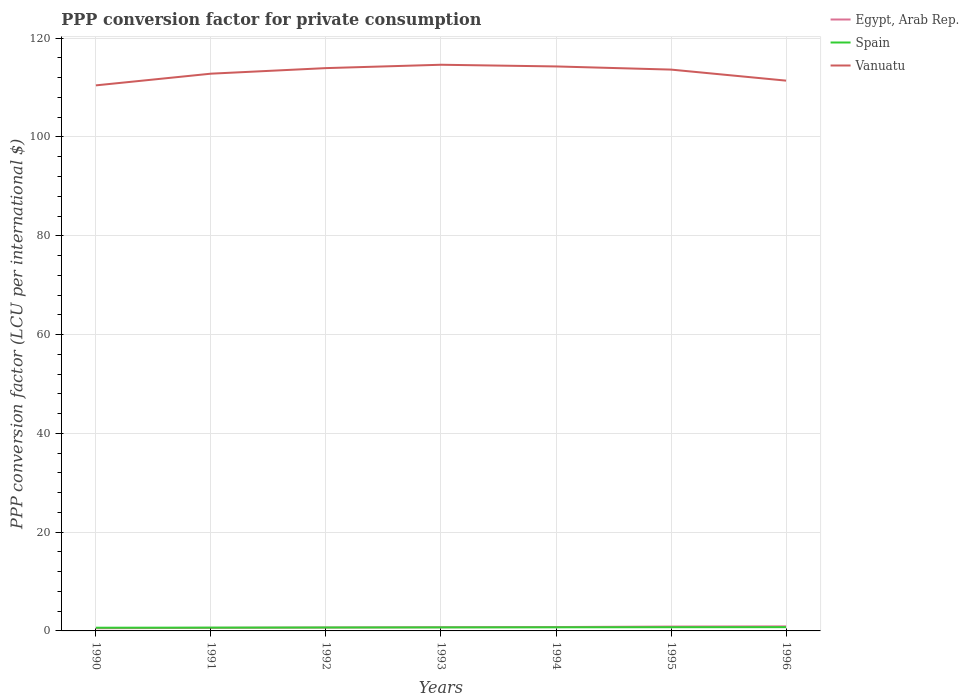How many different coloured lines are there?
Provide a succinct answer. 3. Across all years, what is the maximum PPP conversion factor for private consumption in Spain?
Provide a short and direct response. 0.65. In which year was the PPP conversion factor for private consumption in Egypt, Arab Rep. maximum?
Keep it short and to the point. 1990. What is the total PPP conversion factor for private consumption in Egypt, Arab Rep. in the graph?
Provide a short and direct response. -0.18. What is the difference between the highest and the second highest PPP conversion factor for private consumption in Vanuatu?
Provide a succinct answer. 4.17. What is the difference between the highest and the lowest PPP conversion factor for private consumption in Spain?
Keep it short and to the point. 4. Is the PPP conversion factor for private consumption in Vanuatu strictly greater than the PPP conversion factor for private consumption in Egypt, Arab Rep. over the years?
Your answer should be very brief. No. How many lines are there?
Keep it short and to the point. 3. How many years are there in the graph?
Ensure brevity in your answer.  7. What is the difference between two consecutive major ticks on the Y-axis?
Offer a very short reply. 20. Are the values on the major ticks of Y-axis written in scientific E-notation?
Offer a very short reply. No. What is the title of the graph?
Offer a terse response. PPP conversion factor for private consumption. Does "Aruba" appear as one of the legend labels in the graph?
Make the answer very short. No. What is the label or title of the Y-axis?
Give a very brief answer. PPP conversion factor (LCU per international $). What is the PPP conversion factor (LCU per international $) of Egypt, Arab Rep. in 1990?
Offer a very short reply. 0.54. What is the PPP conversion factor (LCU per international $) in Spain in 1990?
Give a very brief answer. 0.65. What is the PPP conversion factor (LCU per international $) of Vanuatu in 1990?
Your response must be concise. 110.45. What is the PPP conversion factor (LCU per international $) of Egypt, Arab Rep. in 1991?
Offer a terse response. 0.62. What is the PPP conversion factor (LCU per international $) of Spain in 1991?
Provide a succinct answer. 0.67. What is the PPP conversion factor (LCU per international $) in Vanuatu in 1991?
Make the answer very short. 112.81. What is the PPP conversion factor (LCU per international $) of Egypt, Arab Rep. in 1992?
Offer a terse response. 0.68. What is the PPP conversion factor (LCU per international $) of Spain in 1992?
Ensure brevity in your answer.  0.69. What is the PPP conversion factor (LCU per international $) in Vanuatu in 1992?
Offer a very short reply. 113.94. What is the PPP conversion factor (LCU per international $) of Egypt, Arab Rep. in 1993?
Offer a terse response. 0.75. What is the PPP conversion factor (LCU per international $) in Spain in 1993?
Make the answer very short. 0.71. What is the PPP conversion factor (LCU per international $) in Vanuatu in 1993?
Keep it short and to the point. 114.62. What is the PPP conversion factor (LCU per international $) of Egypt, Arab Rep. in 1994?
Provide a succinct answer. 0.79. What is the PPP conversion factor (LCU per international $) in Spain in 1994?
Provide a short and direct response. 0.73. What is the PPP conversion factor (LCU per international $) in Vanuatu in 1994?
Make the answer very short. 114.28. What is the PPP conversion factor (LCU per international $) of Egypt, Arab Rep. in 1995?
Ensure brevity in your answer.  0.88. What is the PPP conversion factor (LCU per international $) in Spain in 1995?
Offer a terse response. 0.75. What is the PPP conversion factor (LCU per international $) of Vanuatu in 1995?
Your response must be concise. 113.64. What is the PPP conversion factor (LCU per international $) in Egypt, Arab Rep. in 1996?
Make the answer very short. 0.92. What is the PPP conversion factor (LCU per international $) in Spain in 1996?
Provide a succinct answer. 0.76. What is the PPP conversion factor (LCU per international $) in Vanuatu in 1996?
Your response must be concise. 111.41. Across all years, what is the maximum PPP conversion factor (LCU per international $) of Egypt, Arab Rep.?
Your answer should be very brief. 0.92. Across all years, what is the maximum PPP conversion factor (LCU per international $) in Spain?
Give a very brief answer. 0.76. Across all years, what is the maximum PPP conversion factor (LCU per international $) of Vanuatu?
Your response must be concise. 114.62. Across all years, what is the minimum PPP conversion factor (LCU per international $) in Egypt, Arab Rep.?
Offer a very short reply. 0.54. Across all years, what is the minimum PPP conversion factor (LCU per international $) of Spain?
Your answer should be compact. 0.65. Across all years, what is the minimum PPP conversion factor (LCU per international $) of Vanuatu?
Provide a short and direct response. 110.45. What is the total PPP conversion factor (LCU per international $) of Egypt, Arab Rep. in the graph?
Your response must be concise. 5.18. What is the total PPP conversion factor (LCU per international $) in Spain in the graph?
Offer a very short reply. 4.98. What is the total PPP conversion factor (LCU per international $) in Vanuatu in the graph?
Your answer should be compact. 791.15. What is the difference between the PPP conversion factor (LCU per international $) in Egypt, Arab Rep. in 1990 and that in 1991?
Your answer should be compact. -0.08. What is the difference between the PPP conversion factor (LCU per international $) of Spain in 1990 and that in 1991?
Offer a terse response. -0.02. What is the difference between the PPP conversion factor (LCU per international $) of Vanuatu in 1990 and that in 1991?
Provide a succinct answer. -2.37. What is the difference between the PPP conversion factor (LCU per international $) in Egypt, Arab Rep. in 1990 and that in 1992?
Offer a very short reply. -0.14. What is the difference between the PPP conversion factor (LCU per international $) in Spain in 1990 and that in 1992?
Offer a very short reply. -0.05. What is the difference between the PPP conversion factor (LCU per international $) in Vanuatu in 1990 and that in 1992?
Provide a short and direct response. -3.49. What is the difference between the PPP conversion factor (LCU per international $) in Egypt, Arab Rep. in 1990 and that in 1993?
Make the answer very short. -0.2. What is the difference between the PPP conversion factor (LCU per international $) of Spain in 1990 and that in 1993?
Offer a very short reply. -0.06. What is the difference between the PPP conversion factor (LCU per international $) of Vanuatu in 1990 and that in 1993?
Your answer should be compact. -4.17. What is the difference between the PPP conversion factor (LCU per international $) in Egypt, Arab Rep. in 1990 and that in 1994?
Make the answer very short. -0.25. What is the difference between the PPP conversion factor (LCU per international $) in Spain in 1990 and that in 1994?
Give a very brief answer. -0.08. What is the difference between the PPP conversion factor (LCU per international $) in Vanuatu in 1990 and that in 1994?
Offer a very short reply. -3.83. What is the difference between the PPP conversion factor (LCU per international $) in Egypt, Arab Rep. in 1990 and that in 1995?
Your answer should be very brief. -0.34. What is the difference between the PPP conversion factor (LCU per international $) in Spain in 1990 and that in 1995?
Provide a succinct answer. -0.1. What is the difference between the PPP conversion factor (LCU per international $) in Vanuatu in 1990 and that in 1995?
Offer a terse response. -3.19. What is the difference between the PPP conversion factor (LCU per international $) of Egypt, Arab Rep. in 1990 and that in 1996?
Your response must be concise. -0.38. What is the difference between the PPP conversion factor (LCU per international $) in Spain in 1990 and that in 1996?
Make the answer very short. -0.11. What is the difference between the PPP conversion factor (LCU per international $) of Vanuatu in 1990 and that in 1996?
Ensure brevity in your answer.  -0.96. What is the difference between the PPP conversion factor (LCU per international $) of Egypt, Arab Rep. in 1991 and that in 1992?
Make the answer very short. -0.06. What is the difference between the PPP conversion factor (LCU per international $) of Spain in 1991 and that in 1992?
Your response must be concise. -0.03. What is the difference between the PPP conversion factor (LCU per international $) in Vanuatu in 1991 and that in 1992?
Ensure brevity in your answer.  -1.13. What is the difference between the PPP conversion factor (LCU per international $) of Egypt, Arab Rep. in 1991 and that in 1993?
Provide a short and direct response. -0.12. What is the difference between the PPP conversion factor (LCU per international $) of Spain in 1991 and that in 1993?
Keep it short and to the point. -0.04. What is the difference between the PPP conversion factor (LCU per international $) in Vanuatu in 1991 and that in 1993?
Offer a very short reply. -1.81. What is the difference between the PPP conversion factor (LCU per international $) of Egypt, Arab Rep. in 1991 and that in 1994?
Offer a very short reply. -0.16. What is the difference between the PPP conversion factor (LCU per international $) in Spain in 1991 and that in 1994?
Keep it short and to the point. -0.06. What is the difference between the PPP conversion factor (LCU per international $) of Vanuatu in 1991 and that in 1994?
Ensure brevity in your answer.  -1.47. What is the difference between the PPP conversion factor (LCU per international $) in Egypt, Arab Rep. in 1991 and that in 1995?
Ensure brevity in your answer.  -0.26. What is the difference between the PPP conversion factor (LCU per international $) in Spain in 1991 and that in 1995?
Give a very brief answer. -0.08. What is the difference between the PPP conversion factor (LCU per international $) in Vanuatu in 1991 and that in 1995?
Offer a very short reply. -0.83. What is the difference between the PPP conversion factor (LCU per international $) of Egypt, Arab Rep. in 1991 and that in 1996?
Offer a terse response. -0.3. What is the difference between the PPP conversion factor (LCU per international $) of Spain in 1991 and that in 1996?
Offer a very short reply. -0.09. What is the difference between the PPP conversion factor (LCU per international $) of Vanuatu in 1991 and that in 1996?
Provide a succinct answer. 1.41. What is the difference between the PPP conversion factor (LCU per international $) in Egypt, Arab Rep. in 1992 and that in 1993?
Keep it short and to the point. -0.06. What is the difference between the PPP conversion factor (LCU per international $) of Spain in 1992 and that in 1993?
Provide a short and direct response. -0.02. What is the difference between the PPP conversion factor (LCU per international $) in Vanuatu in 1992 and that in 1993?
Your answer should be very brief. -0.68. What is the difference between the PPP conversion factor (LCU per international $) in Egypt, Arab Rep. in 1992 and that in 1994?
Your response must be concise. -0.1. What is the difference between the PPP conversion factor (LCU per international $) of Spain in 1992 and that in 1994?
Your answer should be compact. -0.04. What is the difference between the PPP conversion factor (LCU per international $) of Vanuatu in 1992 and that in 1994?
Make the answer very short. -0.34. What is the difference between the PPP conversion factor (LCU per international $) in Egypt, Arab Rep. in 1992 and that in 1995?
Provide a succinct answer. -0.2. What is the difference between the PPP conversion factor (LCU per international $) in Spain in 1992 and that in 1995?
Ensure brevity in your answer.  -0.06. What is the difference between the PPP conversion factor (LCU per international $) in Vanuatu in 1992 and that in 1995?
Give a very brief answer. 0.3. What is the difference between the PPP conversion factor (LCU per international $) of Egypt, Arab Rep. in 1992 and that in 1996?
Your answer should be compact. -0.24. What is the difference between the PPP conversion factor (LCU per international $) in Spain in 1992 and that in 1996?
Provide a short and direct response. -0.07. What is the difference between the PPP conversion factor (LCU per international $) in Vanuatu in 1992 and that in 1996?
Your answer should be compact. 2.54. What is the difference between the PPP conversion factor (LCU per international $) of Egypt, Arab Rep. in 1993 and that in 1994?
Your answer should be very brief. -0.04. What is the difference between the PPP conversion factor (LCU per international $) in Spain in 1993 and that in 1994?
Provide a short and direct response. -0.02. What is the difference between the PPP conversion factor (LCU per international $) in Vanuatu in 1993 and that in 1994?
Make the answer very short. 0.34. What is the difference between the PPP conversion factor (LCU per international $) in Egypt, Arab Rep. in 1993 and that in 1995?
Provide a short and direct response. -0.14. What is the difference between the PPP conversion factor (LCU per international $) of Spain in 1993 and that in 1995?
Offer a terse response. -0.04. What is the difference between the PPP conversion factor (LCU per international $) of Vanuatu in 1993 and that in 1995?
Keep it short and to the point. 0.98. What is the difference between the PPP conversion factor (LCU per international $) in Egypt, Arab Rep. in 1993 and that in 1996?
Your answer should be compact. -0.18. What is the difference between the PPP conversion factor (LCU per international $) in Spain in 1993 and that in 1996?
Give a very brief answer. -0.05. What is the difference between the PPP conversion factor (LCU per international $) of Vanuatu in 1993 and that in 1996?
Keep it short and to the point. 3.22. What is the difference between the PPP conversion factor (LCU per international $) of Egypt, Arab Rep. in 1994 and that in 1995?
Give a very brief answer. -0.1. What is the difference between the PPP conversion factor (LCU per international $) of Spain in 1994 and that in 1995?
Give a very brief answer. -0.02. What is the difference between the PPP conversion factor (LCU per international $) in Vanuatu in 1994 and that in 1995?
Make the answer very short. 0.64. What is the difference between the PPP conversion factor (LCU per international $) of Egypt, Arab Rep. in 1994 and that in 1996?
Keep it short and to the point. -0.14. What is the difference between the PPP conversion factor (LCU per international $) in Spain in 1994 and that in 1996?
Make the answer very short. -0.03. What is the difference between the PPP conversion factor (LCU per international $) of Vanuatu in 1994 and that in 1996?
Give a very brief answer. 2.88. What is the difference between the PPP conversion factor (LCU per international $) in Egypt, Arab Rep. in 1995 and that in 1996?
Your response must be concise. -0.04. What is the difference between the PPP conversion factor (LCU per international $) of Spain in 1995 and that in 1996?
Provide a succinct answer. -0.01. What is the difference between the PPP conversion factor (LCU per international $) of Vanuatu in 1995 and that in 1996?
Ensure brevity in your answer.  2.24. What is the difference between the PPP conversion factor (LCU per international $) in Egypt, Arab Rep. in 1990 and the PPP conversion factor (LCU per international $) in Spain in 1991?
Ensure brevity in your answer.  -0.13. What is the difference between the PPP conversion factor (LCU per international $) in Egypt, Arab Rep. in 1990 and the PPP conversion factor (LCU per international $) in Vanuatu in 1991?
Ensure brevity in your answer.  -112.27. What is the difference between the PPP conversion factor (LCU per international $) of Spain in 1990 and the PPP conversion factor (LCU per international $) of Vanuatu in 1991?
Your answer should be compact. -112.17. What is the difference between the PPP conversion factor (LCU per international $) in Egypt, Arab Rep. in 1990 and the PPP conversion factor (LCU per international $) in Spain in 1992?
Make the answer very short. -0.15. What is the difference between the PPP conversion factor (LCU per international $) of Egypt, Arab Rep. in 1990 and the PPP conversion factor (LCU per international $) of Vanuatu in 1992?
Your response must be concise. -113.4. What is the difference between the PPP conversion factor (LCU per international $) in Spain in 1990 and the PPP conversion factor (LCU per international $) in Vanuatu in 1992?
Make the answer very short. -113.29. What is the difference between the PPP conversion factor (LCU per international $) of Egypt, Arab Rep. in 1990 and the PPP conversion factor (LCU per international $) of Spain in 1993?
Your response must be concise. -0.17. What is the difference between the PPP conversion factor (LCU per international $) in Egypt, Arab Rep. in 1990 and the PPP conversion factor (LCU per international $) in Vanuatu in 1993?
Provide a short and direct response. -114.08. What is the difference between the PPP conversion factor (LCU per international $) in Spain in 1990 and the PPP conversion factor (LCU per international $) in Vanuatu in 1993?
Your response must be concise. -113.97. What is the difference between the PPP conversion factor (LCU per international $) in Egypt, Arab Rep. in 1990 and the PPP conversion factor (LCU per international $) in Spain in 1994?
Give a very brief answer. -0.19. What is the difference between the PPP conversion factor (LCU per international $) of Egypt, Arab Rep. in 1990 and the PPP conversion factor (LCU per international $) of Vanuatu in 1994?
Your response must be concise. -113.74. What is the difference between the PPP conversion factor (LCU per international $) of Spain in 1990 and the PPP conversion factor (LCU per international $) of Vanuatu in 1994?
Keep it short and to the point. -113.63. What is the difference between the PPP conversion factor (LCU per international $) in Egypt, Arab Rep. in 1990 and the PPP conversion factor (LCU per international $) in Spain in 1995?
Your response must be concise. -0.21. What is the difference between the PPP conversion factor (LCU per international $) in Egypt, Arab Rep. in 1990 and the PPP conversion factor (LCU per international $) in Vanuatu in 1995?
Make the answer very short. -113.1. What is the difference between the PPP conversion factor (LCU per international $) of Spain in 1990 and the PPP conversion factor (LCU per international $) of Vanuatu in 1995?
Offer a terse response. -112.99. What is the difference between the PPP conversion factor (LCU per international $) in Egypt, Arab Rep. in 1990 and the PPP conversion factor (LCU per international $) in Spain in 1996?
Ensure brevity in your answer.  -0.22. What is the difference between the PPP conversion factor (LCU per international $) of Egypt, Arab Rep. in 1990 and the PPP conversion factor (LCU per international $) of Vanuatu in 1996?
Provide a short and direct response. -110.87. What is the difference between the PPP conversion factor (LCU per international $) of Spain in 1990 and the PPP conversion factor (LCU per international $) of Vanuatu in 1996?
Provide a succinct answer. -110.76. What is the difference between the PPP conversion factor (LCU per international $) of Egypt, Arab Rep. in 1991 and the PPP conversion factor (LCU per international $) of Spain in 1992?
Keep it short and to the point. -0.07. What is the difference between the PPP conversion factor (LCU per international $) of Egypt, Arab Rep. in 1991 and the PPP conversion factor (LCU per international $) of Vanuatu in 1992?
Make the answer very short. -113.32. What is the difference between the PPP conversion factor (LCU per international $) of Spain in 1991 and the PPP conversion factor (LCU per international $) of Vanuatu in 1992?
Your answer should be very brief. -113.27. What is the difference between the PPP conversion factor (LCU per international $) of Egypt, Arab Rep. in 1991 and the PPP conversion factor (LCU per international $) of Spain in 1993?
Keep it short and to the point. -0.09. What is the difference between the PPP conversion factor (LCU per international $) of Egypt, Arab Rep. in 1991 and the PPP conversion factor (LCU per international $) of Vanuatu in 1993?
Ensure brevity in your answer.  -114. What is the difference between the PPP conversion factor (LCU per international $) in Spain in 1991 and the PPP conversion factor (LCU per international $) in Vanuatu in 1993?
Your response must be concise. -113.95. What is the difference between the PPP conversion factor (LCU per international $) of Egypt, Arab Rep. in 1991 and the PPP conversion factor (LCU per international $) of Spain in 1994?
Offer a very short reply. -0.11. What is the difference between the PPP conversion factor (LCU per international $) in Egypt, Arab Rep. in 1991 and the PPP conversion factor (LCU per international $) in Vanuatu in 1994?
Provide a succinct answer. -113.66. What is the difference between the PPP conversion factor (LCU per international $) of Spain in 1991 and the PPP conversion factor (LCU per international $) of Vanuatu in 1994?
Your response must be concise. -113.61. What is the difference between the PPP conversion factor (LCU per international $) in Egypt, Arab Rep. in 1991 and the PPP conversion factor (LCU per international $) in Spain in 1995?
Your answer should be very brief. -0.13. What is the difference between the PPP conversion factor (LCU per international $) of Egypt, Arab Rep. in 1991 and the PPP conversion factor (LCU per international $) of Vanuatu in 1995?
Make the answer very short. -113.02. What is the difference between the PPP conversion factor (LCU per international $) in Spain in 1991 and the PPP conversion factor (LCU per international $) in Vanuatu in 1995?
Give a very brief answer. -112.97. What is the difference between the PPP conversion factor (LCU per international $) in Egypt, Arab Rep. in 1991 and the PPP conversion factor (LCU per international $) in Spain in 1996?
Your response must be concise. -0.14. What is the difference between the PPP conversion factor (LCU per international $) of Egypt, Arab Rep. in 1991 and the PPP conversion factor (LCU per international $) of Vanuatu in 1996?
Ensure brevity in your answer.  -110.79. What is the difference between the PPP conversion factor (LCU per international $) in Spain in 1991 and the PPP conversion factor (LCU per international $) in Vanuatu in 1996?
Offer a terse response. -110.74. What is the difference between the PPP conversion factor (LCU per international $) in Egypt, Arab Rep. in 1992 and the PPP conversion factor (LCU per international $) in Spain in 1993?
Make the answer very short. -0.03. What is the difference between the PPP conversion factor (LCU per international $) of Egypt, Arab Rep. in 1992 and the PPP conversion factor (LCU per international $) of Vanuatu in 1993?
Offer a terse response. -113.94. What is the difference between the PPP conversion factor (LCU per international $) of Spain in 1992 and the PPP conversion factor (LCU per international $) of Vanuatu in 1993?
Your answer should be compact. -113.93. What is the difference between the PPP conversion factor (LCU per international $) of Egypt, Arab Rep. in 1992 and the PPP conversion factor (LCU per international $) of Spain in 1994?
Make the answer very short. -0.05. What is the difference between the PPP conversion factor (LCU per international $) of Egypt, Arab Rep. in 1992 and the PPP conversion factor (LCU per international $) of Vanuatu in 1994?
Your answer should be very brief. -113.6. What is the difference between the PPP conversion factor (LCU per international $) in Spain in 1992 and the PPP conversion factor (LCU per international $) in Vanuatu in 1994?
Offer a terse response. -113.59. What is the difference between the PPP conversion factor (LCU per international $) in Egypt, Arab Rep. in 1992 and the PPP conversion factor (LCU per international $) in Spain in 1995?
Provide a succinct answer. -0.07. What is the difference between the PPP conversion factor (LCU per international $) of Egypt, Arab Rep. in 1992 and the PPP conversion factor (LCU per international $) of Vanuatu in 1995?
Keep it short and to the point. -112.96. What is the difference between the PPP conversion factor (LCU per international $) in Spain in 1992 and the PPP conversion factor (LCU per international $) in Vanuatu in 1995?
Offer a very short reply. -112.95. What is the difference between the PPP conversion factor (LCU per international $) in Egypt, Arab Rep. in 1992 and the PPP conversion factor (LCU per international $) in Spain in 1996?
Ensure brevity in your answer.  -0.08. What is the difference between the PPP conversion factor (LCU per international $) in Egypt, Arab Rep. in 1992 and the PPP conversion factor (LCU per international $) in Vanuatu in 1996?
Your answer should be very brief. -110.72. What is the difference between the PPP conversion factor (LCU per international $) of Spain in 1992 and the PPP conversion factor (LCU per international $) of Vanuatu in 1996?
Your answer should be compact. -110.71. What is the difference between the PPP conversion factor (LCU per international $) in Egypt, Arab Rep. in 1993 and the PPP conversion factor (LCU per international $) in Spain in 1994?
Keep it short and to the point. 0.01. What is the difference between the PPP conversion factor (LCU per international $) in Egypt, Arab Rep. in 1993 and the PPP conversion factor (LCU per international $) in Vanuatu in 1994?
Your answer should be very brief. -113.54. What is the difference between the PPP conversion factor (LCU per international $) in Spain in 1993 and the PPP conversion factor (LCU per international $) in Vanuatu in 1994?
Your response must be concise. -113.57. What is the difference between the PPP conversion factor (LCU per international $) of Egypt, Arab Rep. in 1993 and the PPP conversion factor (LCU per international $) of Spain in 1995?
Make the answer very short. -0.01. What is the difference between the PPP conversion factor (LCU per international $) of Egypt, Arab Rep. in 1993 and the PPP conversion factor (LCU per international $) of Vanuatu in 1995?
Your answer should be compact. -112.9. What is the difference between the PPP conversion factor (LCU per international $) in Spain in 1993 and the PPP conversion factor (LCU per international $) in Vanuatu in 1995?
Give a very brief answer. -112.93. What is the difference between the PPP conversion factor (LCU per international $) in Egypt, Arab Rep. in 1993 and the PPP conversion factor (LCU per international $) in Spain in 1996?
Your answer should be very brief. -0.02. What is the difference between the PPP conversion factor (LCU per international $) of Egypt, Arab Rep. in 1993 and the PPP conversion factor (LCU per international $) of Vanuatu in 1996?
Keep it short and to the point. -110.66. What is the difference between the PPP conversion factor (LCU per international $) in Spain in 1993 and the PPP conversion factor (LCU per international $) in Vanuatu in 1996?
Provide a short and direct response. -110.69. What is the difference between the PPP conversion factor (LCU per international $) of Egypt, Arab Rep. in 1994 and the PPP conversion factor (LCU per international $) of Spain in 1995?
Make the answer very short. 0.03. What is the difference between the PPP conversion factor (LCU per international $) in Egypt, Arab Rep. in 1994 and the PPP conversion factor (LCU per international $) in Vanuatu in 1995?
Offer a very short reply. -112.86. What is the difference between the PPP conversion factor (LCU per international $) of Spain in 1994 and the PPP conversion factor (LCU per international $) of Vanuatu in 1995?
Your answer should be compact. -112.91. What is the difference between the PPP conversion factor (LCU per international $) in Egypt, Arab Rep. in 1994 and the PPP conversion factor (LCU per international $) in Spain in 1996?
Your answer should be very brief. 0.02. What is the difference between the PPP conversion factor (LCU per international $) of Egypt, Arab Rep. in 1994 and the PPP conversion factor (LCU per international $) of Vanuatu in 1996?
Your answer should be very brief. -110.62. What is the difference between the PPP conversion factor (LCU per international $) in Spain in 1994 and the PPP conversion factor (LCU per international $) in Vanuatu in 1996?
Offer a terse response. -110.67. What is the difference between the PPP conversion factor (LCU per international $) in Egypt, Arab Rep. in 1995 and the PPP conversion factor (LCU per international $) in Spain in 1996?
Your response must be concise. 0.12. What is the difference between the PPP conversion factor (LCU per international $) in Egypt, Arab Rep. in 1995 and the PPP conversion factor (LCU per international $) in Vanuatu in 1996?
Offer a very short reply. -110.52. What is the difference between the PPP conversion factor (LCU per international $) in Spain in 1995 and the PPP conversion factor (LCU per international $) in Vanuatu in 1996?
Your answer should be very brief. -110.65. What is the average PPP conversion factor (LCU per international $) of Egypt, Arab Rep. per year?
Provide a succinct answer. 0.74. What is the average PPP conversion factor (LCU per international $) of Spain per year?
Your answer should be very brief. 0.71. What is the average PPP conversion factor (LCU per international $) in Vanuatu per year?
Give a very brief answer. 113.02. In the year 1990, what is the difference between the PPP conversion factor (LCU per international $) of Egypt, Arab Rep. and PPP conversion factor (LCU per international $) of Spain?
Your response must be concise. -0.11. In the year 1990, what is the difference between the PPP conversion factor (LCU per international $) in Egypt, Arab Rep. and PPP conversion factor (LCU per international $) in Vanuatu?
Your response must be concise. -109.91. In the year 1990, what is the difference between the PPP conversion factor (LCU per international $) of Spain and PPP conversion factor (LCU per international $) of Vanuatu?
Offer a terse response. -109.8. In the year 1991, what is the difference between the PPP conversion factor (LCU per international $) in Egypt, Arab Rep. and PPP conversion factor (LCU per international $) in Spain?
Ensure brevity in your answer.  -0.05. In the year 1991, what is the difference between the PPP conversion factor (LCU per international $) in Egypt, Arab Rep. and PPP conversion factor (LCU per international $) in Vanuatu?
Your answer should be very brief. -112.19. In the year 1991, what is the difference between the PPP conversion factor (LCU per international $) in Spain and PPP conversion factor (LCU per international $) in Vanuatu?
Your answer should be very brief. -112.15. In the year 1992, what is the difference between the PPP conversion factor (LCU per international $) of Egypt, Arab Rep. and PPP conversion factor (LCU per international $) of Spain?
Offer a terse response. -0.01. In the year 1992, what is the difference between the PPP conversion factor (LCU per international $) of Egypt, Arab Rep. and PPP conversion factor (LCU per international $) of Vanuatu?
Make the answer very short. -113.26. In the year 1992, what is the difference between the PPP conversion factor (LCU per international $) in Spain and PPP conversion factor (LCU per international $) in Vanuatu?
Your answer should be very brief. -113.25. In the year 1993, what is the difference between the PPP conversion factor (LCU per international $) of Egypt, Arab Rep. and PPP conversion factor (LCU per international $) of Spain?
Your answer should be compact. 0.03. In the year 1993, what is the difference between the PPP conversion factor (LCU per international $) of Egypt, Arab Rep. and PPP conversion factor (LCU per international $) of Vanuatu?
Offer a very short reply. -113.88. In the year 1993, what is the difference between the PPP conversion factor (LCU per international $) of Spain and PPP conversion factor (LCU per international $) of Vanuatu?
Your answer should be very brief. -113.91. In the year 1994, what is the difference between the PPP conversion factor (LCU per international $) in Egypt, Arab Rep. and PPP conversion factor (LCU per international $) in Spain?
Make the answer very short. 0.05. In the year 1994, what is the difference between the PPP conversion factor (LCU per international $) of Egypt, Arab Rep. and PPP conversion factor (LCU per international $) of Vanuatu?
Make the answer very short. -113.5. In the year 1994, what is the difference between the PPP conversion factor (LCU per international $) in Spain and PPP conversion factor (LCU per international $) in Vanuatu?
Give a very brief answer. -113.55. In the year 1995, what is the difference between the PPP conversion factor (LCU per international $) in Egypt, Arab Rep. and PPP conversion factor (LCU per international $) in Spain?
Provide a succinct answer. 0.13. In the year 1995, what is the difference between the PPP conversion factor (LCU per international $) in Egypt, Arab Rep. and PPP conversion factor (LCU per international $) in Vanuatu?
Your answer should be compact. -112.76. In the year 1995, what is the difference between the PPP conversion factor (LCU per international $) in Spain and PPP conversion factor (LCU per international $) in Vanuatu?
Offer a very short reply. -112.89. In the year 1996, what is the difference between the PPP conversion factor (LCU per international $) in Egypt, Arab Rep. and PPP conversion factor (LCU per international $) in Spain?
Keep it short and to the point. 0.16. In the year 1996, what is the difference between the PPP conversion factor (LCU per international $) of Egypt, Arab Rep. and PPP conversion factor (LCU per international $) of Vanuatu?
Offer a terse response. -110.49. In the year 1996, what is the difference between the PPP conversion factor (LCU per international $) of Spain and PPP conversion factor (LCU per international $) of Vanuatu?
Offer a very short reply. -110.64. What is the ratio of the PPP conversion factor (LCU per international $) of Egypt, Arab Rep. in 1990 to that in 1991?
Give a very brief answer. 0.87. What is the ratio of the PPP conversion factor (LCU per international $) in Spain in 1990 to that in 1991?
Offer a terse response. 0.97. What is the ratio of the PPP conversion factor (LCU per international $) of Vanuatu in 1990 to that in 1991?
Provide a succinct answer. 0.98. What is the ratio of the PPP conversion factor (LCU per international $) of Egypt, Arab Rep. in 1990 to that in 1992?
Your answer should be compact. 0.79. What is the ratio of the PPP conversion factor (LCU per international $) in Spain in 1990 to that in 1992?
Your answer should be compact. 0.93. What is the ratio of the PPP conversion factor (LCU per international $) in Vanuatu in 1990 to that in 1992?
Offer a terse response. 0.97. What is the ratio of the PPP conversion factor (LCU per international $) in Egypt, Arab Rep. in 1990 to that in 1993?
Offer a very short reply. 0.72. What is the ratio of the PPP conversion factor (LCU per international $) in Spain in 1990 to that in 1993?
Give a very brief answer. 0.91. What is the ratio of the PPP conversion factor (LCU per international $) of Vanuatu in 1990 to that in 1993?
Ensure brevity in your answer.  0.96. What is the ratio of the PPP conversion factor (LCU per international $) in Egypt, Arab Rep. in 1990 to that in 1994?
Offer a terse response. 0.69. What is the ratio of the PPP conversion factor (LCU per international $) in Spain in 1990 to that in 1994?
Your answer should be very brief. 0.89. What is the ratio of the PPP conversion factor (LCU per international $) in Vanuatu in 1990 to that in 1994?
Keep it short and to the point. 0.97. What is the ratio of the PPP conversion factor (LCU per international $) in Egypt, Arab Rep. in 1990 to that in 1995?
Offer a very short reply. 0.61. What is the ratio of the PPP conversion factor (LCU per international $) of Spain in 1990 to that in 1995?
Keep it short and to the point. 0.86. What is the ratio of the PPP conversion factor (LCU per international $) of Vanuatu in 1990 to that in 1995?
Keep it short and to the point. 0.97. What is the ratio of the PPP conversion factor (LCU per international $) in Egypt, Arab Rep. in 1990 to that in 1996?
Provide a short and direct response. 0.59. What is the ratio of the PPP conversion factor (LCU per international $) in Spain in 1990 to that in 1996?
Your response must be concise. 0.85. What is the ratio of the PPP conversion factor (LCU per international $) of Vanuatu in 1990 to that in 1996?
Provide a succinct answer. 0.99. What is the ratio of the PPP conversion factor (LCU per international $) in Egypt, Arab Rep. in 1991 to that in 1992?
Your answer should be very brief. 0.91. What is the ratio of the PPP conversion factor (LCU per international $) in Spain in 1991 to that in 1992?
Offer a very short reply. 0.96. What is the ratio of the PPP conversion factor (LCU per international $) in Egypt, Arab Rep. in 1991 to that in 1993?
Your response must be concise. 0.83. What is the ratio of the PPP conversion factor (LCU per international $) in Vanuatu in 1991 to that in 1993?
Provide a short and direct response. 0.98. What is the ratio of the PPP conversion factor (LCU per international $) of Egypt, Arab Rep. in 1991 to that in 1994?
Your answer should be very brief. 0.79. What is the ratio of the PPP conversion factor (LCU per international $) of Spain in 1991 to that in 1994?
Your response must be concise. 0.91. What is the ratio of the PPP conversion factor (LCU per international $) in Vanuatu in 1991 to that in 1994?
Give a very brief answer. 0.99. What is the ratio of the PPP conversion factor (LCU per international $) in Egypt, Arab Rep. in 1991 to that in 1995?
Give a very brief answer. 0.7. What is the ratio of the PPP conversion factor (LCU per international $) in Spain in 1991 to that in 1995?
Provide a succinct answer. 0.89. What is the ratio of the PPP conversion factor (LCU per international $) of Egypt, Arab Rep. in 1991 to that in 1996?
Offer a very short reply. 0.67. What is the ratio of the PPP conversion factor (LCU per international $) of Spain in 1991 to that in 1996?
Make the answer very short. 0.88. What is the ratio of the PPP conversion factor (LCU per international $) in Vanuatu in 1991 to that in 1996?
Your answer should be very brief. 1.01. What is the ratio of the PPP conversion factor (LCU per international $) in Egypt, Arab Rep. in 1992 to that in 1993?
Provide a succinct answer. 0.92. What is the ratio of the PPP conversion factor (LCU per international $) in Spain in 1992 to that in 1993?
Provide a succinct answer. 0.97. What is the ratio of the PPP conversion factor (LCU per international $) in Vanuatu in 1992 to that in 1993?
Your response must be concise. 0.99. What is the ratio of the PPP conversion factor (LCU per international $) in Egypt, Arab Rep. in 1992 to that in 1994?
Your response must be concise. 0.87. What is the ratio of the PPP conversion factor (LCU per international $) of Spain in 1992 to that in 1994?
Provide a short and direct response. 0.95. What is the ratio of the PPP conversion factor (LCU per international $) of Vanuatu in 1992 to that in 1994?
Your answer should be compact. 1. What is the ratio of the PPP conversion factor (LCU per international $) in Egypt, Arab Rep. in 1992 to that in 1995?
Offer a terse response. 0.77. What is the ratio of the PPP conversion factor (LCU per international $) in Spain in 1992 to that in 1995?
Your answer should be very brief. 0.92. What is the ratio of the PPP conversion factor (LCU per international $) of Egypt, Arab Rep. in 1992 to that in 1996?
Make the answer very short. 0.74. What is the ratio of the PPP conversion factor (LCU per international $) in Spain in 1992 to that in 1996?
Ensure brevity in your answer.  0.91. What is the ratio of the PPP conversion factor (LCU per international $) in Vanuatu in 1992 to that in 1996?
Offer a very short reply. 1.02. What is the ratio of the PPP conversion factor (LCU per international $) of Egypt, Arab Rep. in 1993 to that in 1994?
Provide a succinct answer. 0.95. What is the ratio of the PPP conversion factor (LCU per international $) of Spain in 1993 to that in 1994?
Your answer should be very brief. 0.97. What is the ratio of the PPP conversion factor (LCU per international $) in Vanuatu in 1993 to that in 1994?
Offer a terse response. 1. What is the ratio of the PPP conversion factor (LCU per international $) of Egypt, Arab Rep. in 1993 to that in 1995?
Offer a terse response. 0.84. What is the ratio of the PPP conversion factor (LCU per international $) of Spain in 1993 to that in 1995?
Ensure brevity in your answer.  0.95. What is the ratio of the PPP conversion factor (LCU per international $) in Vanuatu in 1993 to that in 1995?
Ensure brevity in your answer.  1.01. What is the ratio of the PPP conversion factor (LCU per international $) of Egypt, Arab Rep. in 1993 to that in 1996?
Offer a terse response. 0.81. What is the ratio of the PPP conversion factor (LCU per international $) of Spain in 1993 to that in 1996?
Give a very brief answer. 0.93. What is the ratio of the PPP conversion factor (LCU per international $) of Vanuatu in 1993 to that in 1996?
Provide a short and direct response. 1.03. What is the ratio of the PPP conversion factor (LCU per international $) in Egypt, Arab Rep. in 1994 to that in 1995?
Provide a succinct answer. 0.89. What is the ratio of the PPP conversion factor (LCU per international $) in Spain in 1994 to that in 1995?
Your answer should be compact. 0.97. What is the ratio of the PPP conversion factor (LCU per international $) in Vanuatu in 1994 to that in 1995?
Your response must be concise. 1.01. What is the ratio of the PPP conversion factor (LCU per international $) of Egypt, Arab Rep. in 1994 to that in 1996?
Make the answer very short. 0.85. What is the ratio of the PPP conversion factor (LCU per international $) in Spain in 1994 to that in 1996?
Keep it short and to the point. 0.96. What is the ratio of the PPP conversion factor (LCU per international $) in Vanuatu in 1994 to that in 1996?
Offer a very short reply. 1.03. What is the ratio of the PPP conversion factor (LCU per international $) of Egypt, Arab Rep. in 1995 to that in 1996?
Your answer should be very brief. 0.96. What is the ratio of the PPP conversion factor (LCU per international $) of Spain in 1995 to that in 1996?
Provide a short and direct response. 0.99. What is the ratio of the PPP conversion factor (LCU per international $) in Vanuatu in 1995 to that in 1996?
Ensure brevity in your answer.  1.02. What is the difference between the highest and the second highest PPP conversion factor (LCU per international $) in Egypt, Arab Rep.?
Ensure brevity in your answer.  0.04. What is the difference between the highest and the second highest PPP conversion factor (LCU per international $) in Spain?
Provide a short and direct response. 0.01. What is the difference between the highest and the second highest PPP conversion factor (LCU per international $) of Vanuatu?
Your response must be concise. 0.34. What is the difference between the highest and the lowest PPP conversion factor (LCU per international $) in Egypt, Arab Rep.?
Offer a terse response. 0.38. What is the difference between the highest and the lowest PPP conversion factor (LCU per international $) in Spain?
Keep it short and to the point. 0.11. What is the difference between the highest and the lowest PPP conversion factor (LCU per international $) in Vanuatu?
Your answer should be compact. 4.17. 